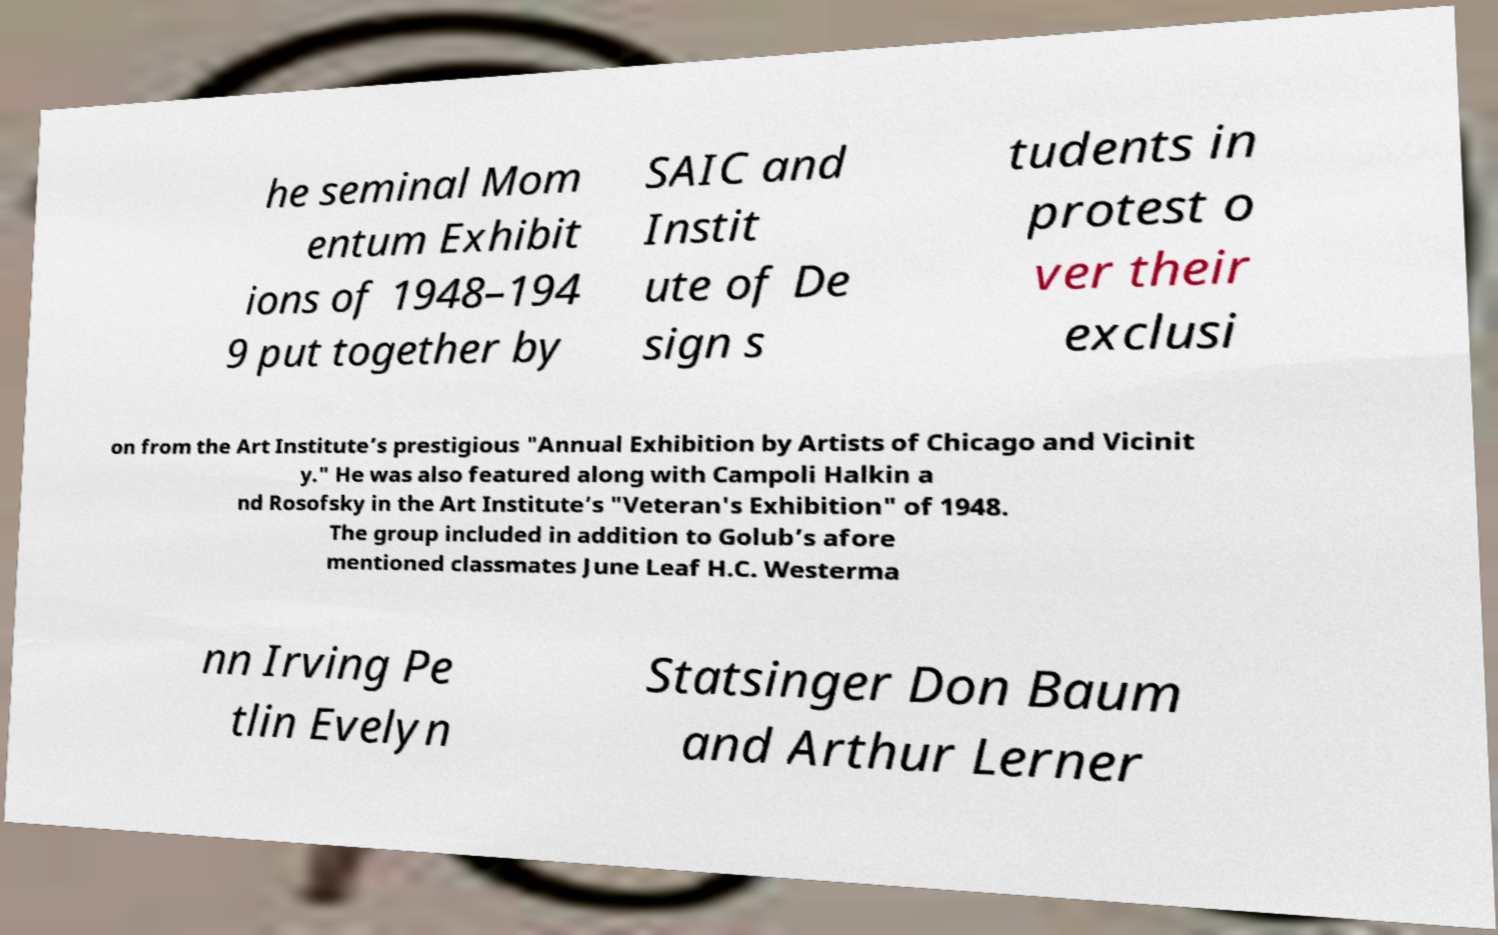Could you extract and type out the text from this image? he seminal Mom entum Exhibit ions of 1948–194 9 put together by SAIC and Instit ute of De sign s tudents in protest o ver their exclusi on from the Art Institute’s prestigious "Annual Exhibition by Artists of Chicago and Vicinit y." He was also featured along with Campoli Halkin a nd Rosofsky in the Art Institute’s "Veteran's Exhibition" of 1948. The group included in addition to Golub’s afore mentioned classmates June Leaf H.C. Westerma nn Irving Pe tlin Evelyn Statsinger Don Baum and Arthur Lerner 